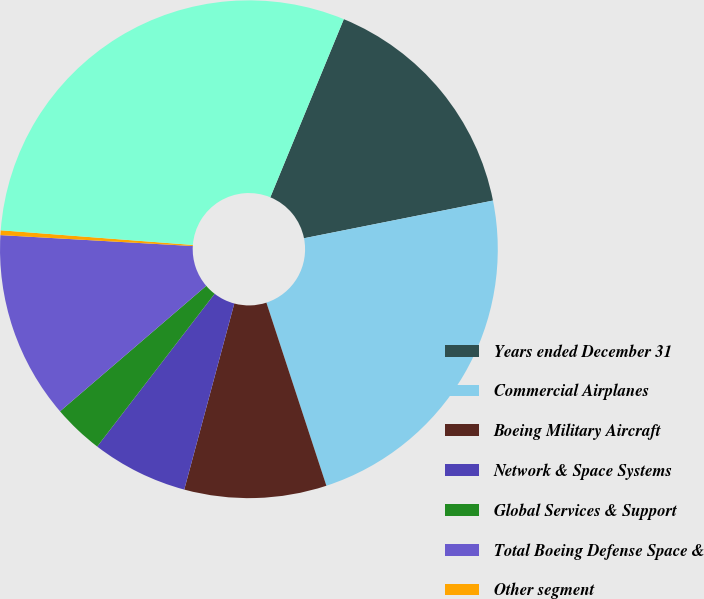Convert chart to OTSL. <chart><loc_0><loc_0><loc_500><loc_500><pie_chart><fcel>Years ended December 31<fcel>Commercial Airplanes<fcel>Boeing Military Aircraft<fcel>Network & Space Systems<fcel>Global Services & Support<fcel>Total Boeing Defense Space &<fcel>Other segment<fcel>Total research and development<nl><fcel>15.64%<fcel>23.09%<fcel>9.22%<fcel>6.25%<fcel>3.28%<fcel>12.19%<fcel>0.31%<fcel>30.01%<nl></chart> 